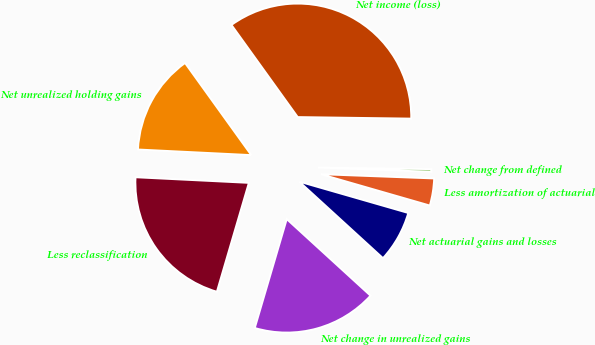Convert chart to OTSL. <chart><loc_0><loc_0><loc_500><loc_500><pie_chart><fcel>Net income (loss)<fcel>Net unrealized holding gains<fcel>Less reclassification<fcel>Net change in unrealized gains<fcel>Net actuarial gains and losses<fcel>Less amortization of actuarial<fcel>Net change from defined<nl><fcel>35.14%<fcel>14.29%<fcel>21.24%<fcel>17.76%<fcel>7.33%<fcel>3.86%<fcel>0.38%<nl></chart> 